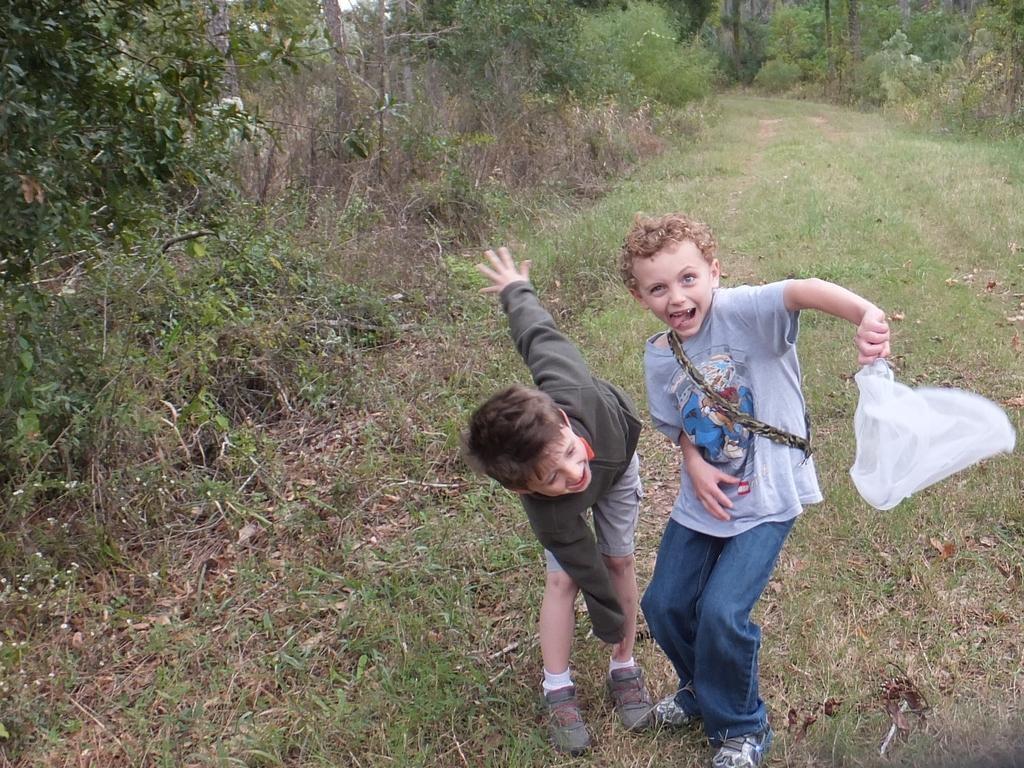How many boys are present in the image? There are two boys in the image. What is the facial expression of the boys? Both boys are smiling. What is the right side boy holding in his hand? The right side boy is holding a cover in his hand. What can be seen in the background of the image? There are trees visible in the background of the image. What type of credit card is the boy holding in the image? There is no credit card visible in the image; the right side boy is holding a cover. 